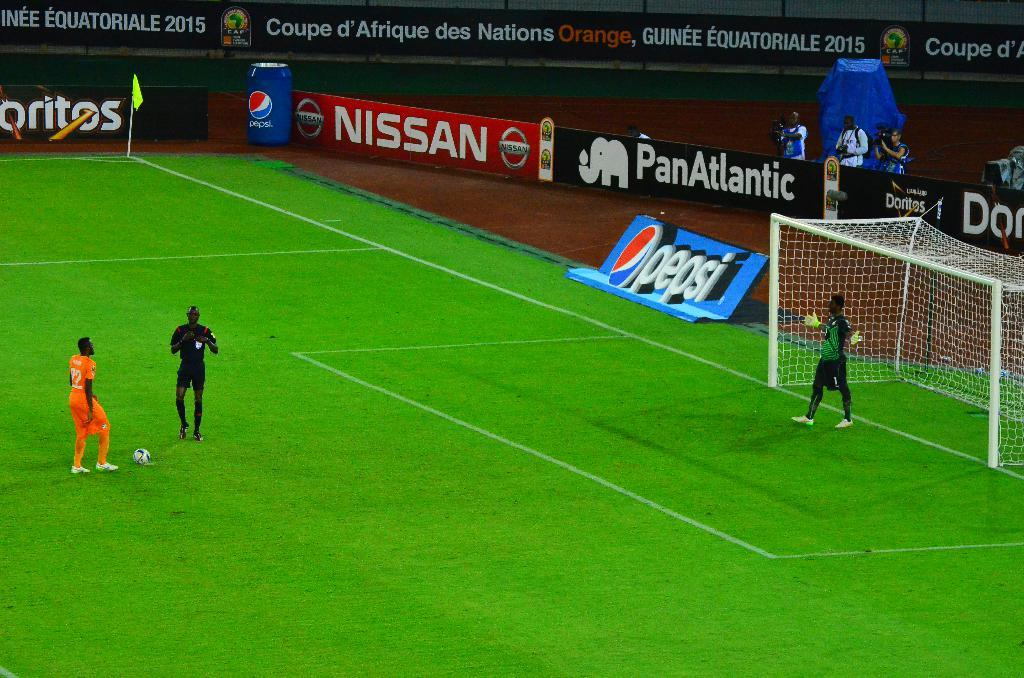<image>
Create a compact narrative representing the image presented. Soccer players stand on the field in front of a Pepsi and Nissan ad 